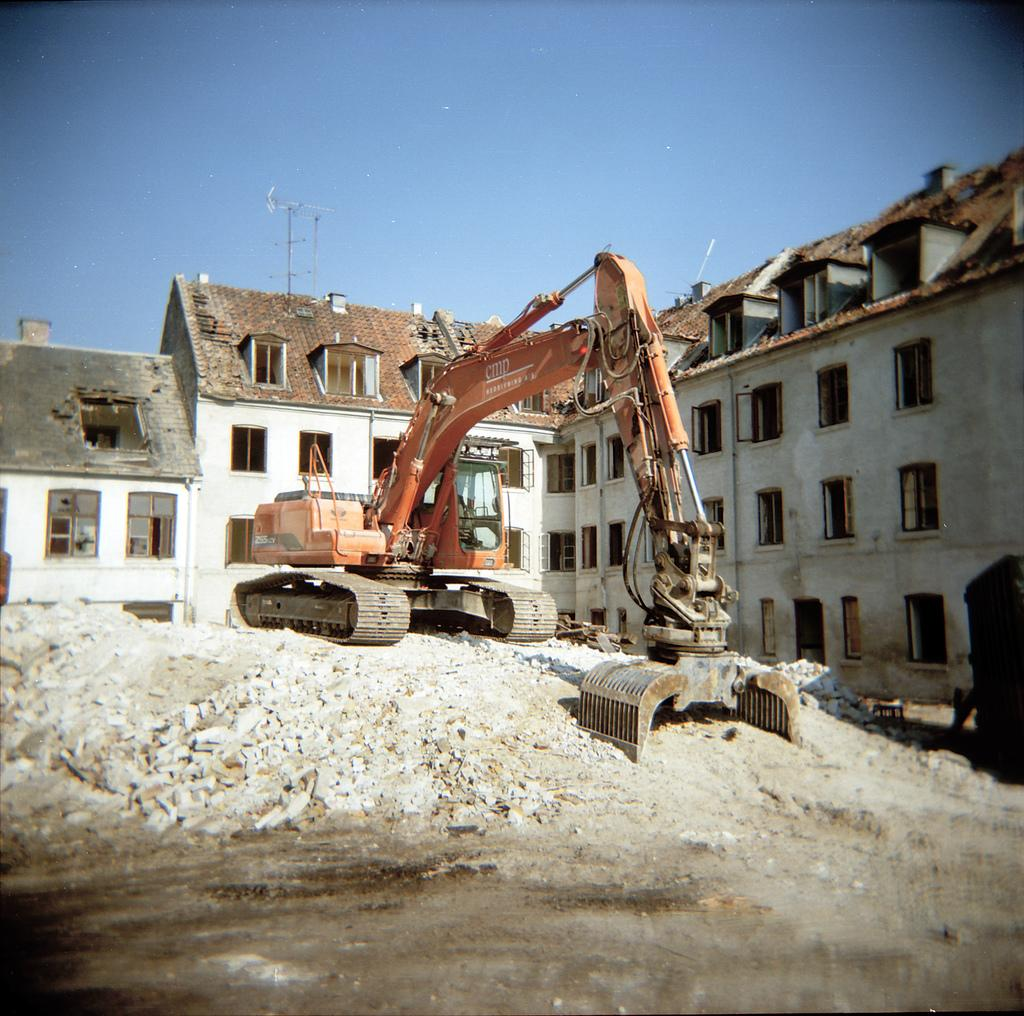What type of vehicle is on the ground in the image? There is an orange color excavator on the ground. What is on top of the excavator? There are stones on the excavator. What can be seen in the background of the image? There are buildings in the background. What type of windows do the buildings have? The buildings have glass windows. What color is the sky in the image? The sky is blue. What type of rake is being used to clean the flight in the image? There is no rake or flight present in the image. 